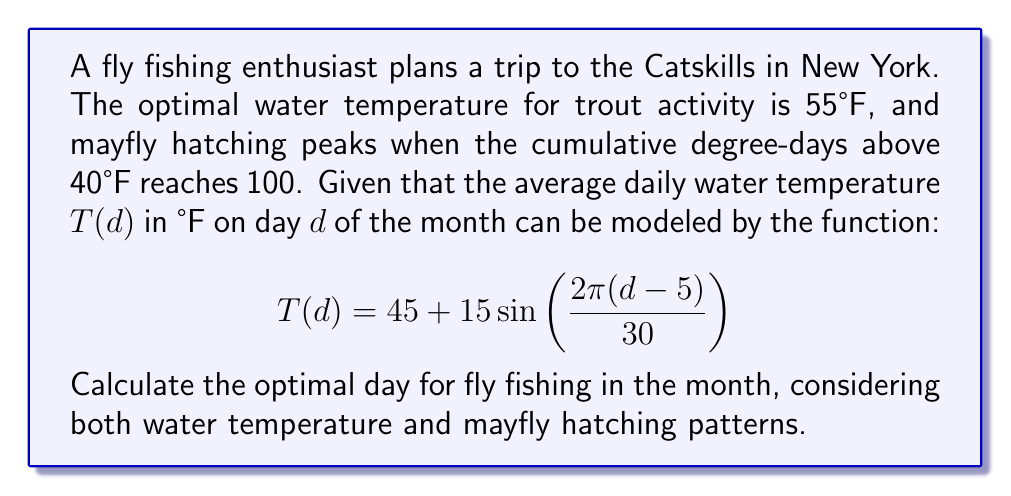Can you answer this question? Let's approach this problem step-by-step:

1) First, we need to find when the water temperature is closest to 55°F. We can do this by solving:

   $$55 = 45 + 15 \sin\left(\frac{2\pi(d-5)}{30}\right)$$

2) Simplifying:
   
   $$\frac{2}{3} = \sin\left(\frac{2\pi(d-5)}{30}\right)$$

3) Taking the inverse sine:

   $$d = 5 + \frac{30}{2\pi} \arcsin\left(\frac{2}{3}\right) \approx 11.8$$

4) The closest integer day is 12.

5) Now, let's calculate the cumulative degree-days. We need to integrate the temperature above 40°F:

   $$DD = \int_1^d (T(x) - 40) dx$$

6) Substituting our temperature function:

   $$DD = \int_1^d \left(5 + 15 \sin\left(\frac{2\pi(x-5)}{30}\right)\right) dx$$

7) Integrating:

   $$DD = 5d - \frac{15 \cdot 30}{2\pi} \cos\left(\frac{2\pi(d-5)}{30}\right) + C$$

8) We want to find when DD = 100. Using a numerical method or graphing, we can find this occurs around day 15.

9) Comparing our two results: day 12 for optimal temperature and day 15 for mayfly hatching, we should choose a day in between to balance both factors.
Answer: Day 13 or 14 of the month 